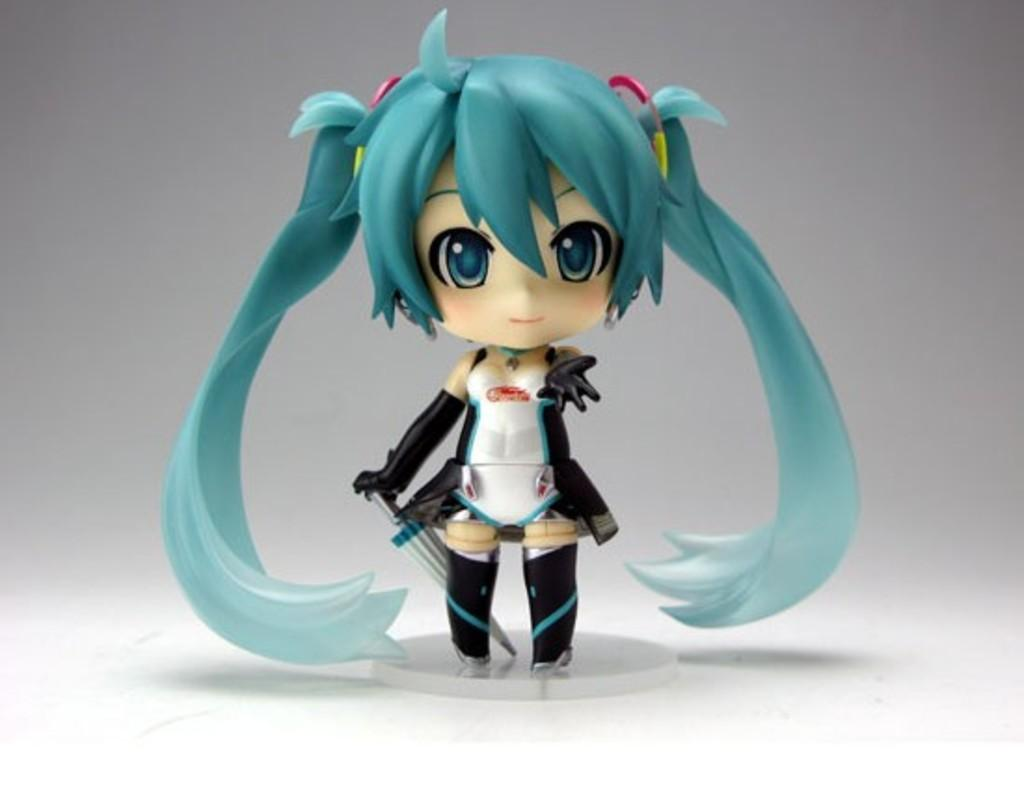What is the main subject of the image? There is a toy of a girl in the image. What color is the background of the image? The background of the image is white. What type of floor can be seen in the image? There is no floor visible in the image; it only shows a toy of a girl against a white background. 